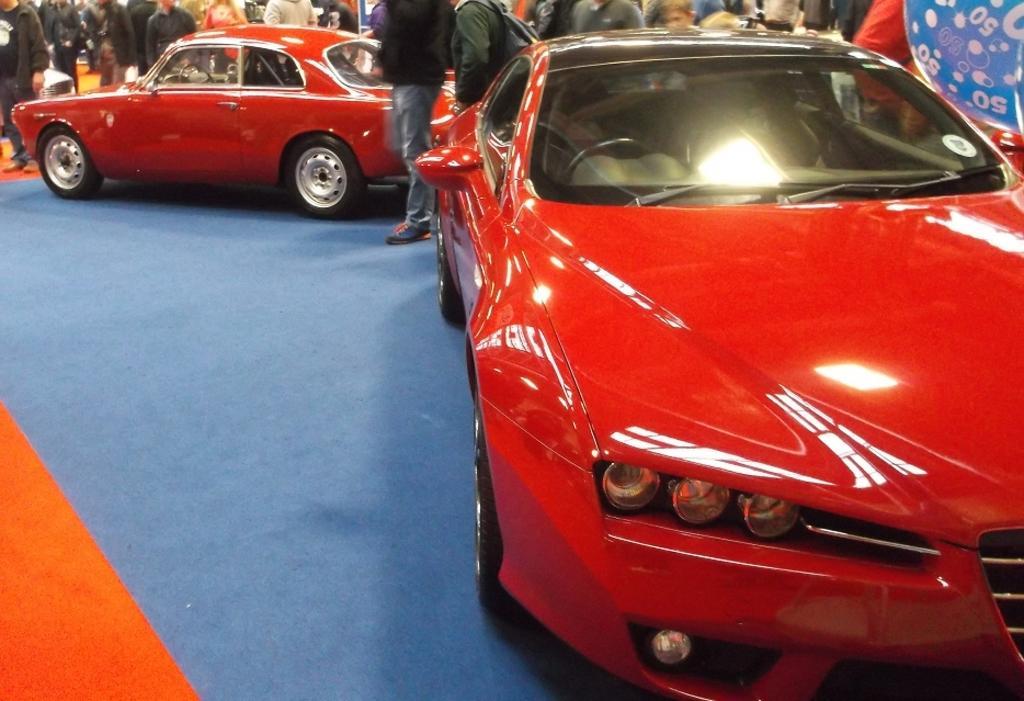In one or two sentences, can you explain what this image depicts? In the foreground of the picture there is a red color car and blue color mat. In the background there are people, car and other objects. 